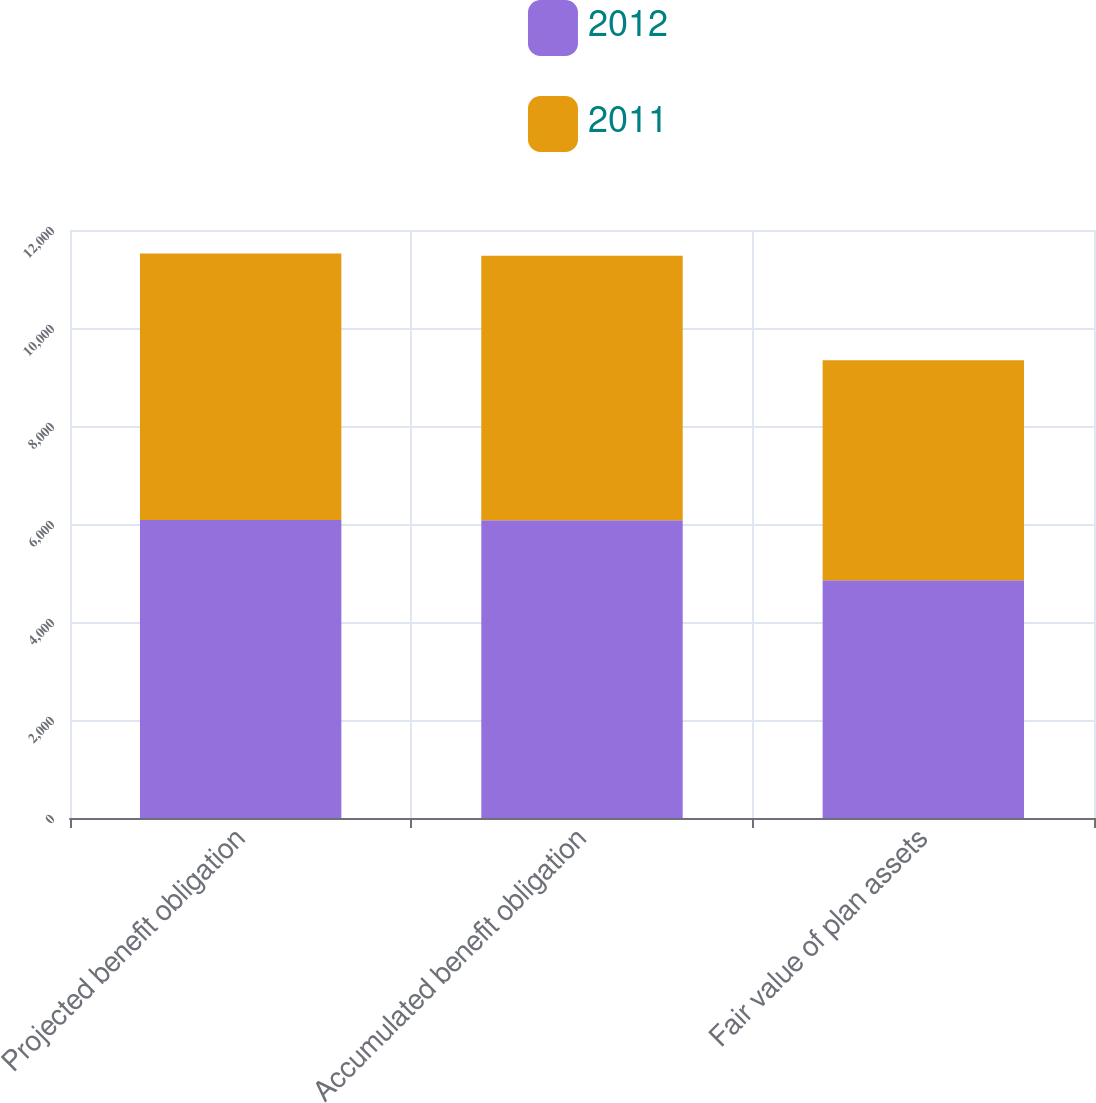<chart> <loc_0><loc_0><loc_500><loc_500><stacked_bar_chart><ecel><fcel>Projected benefit obligation<fcel>Accumulated benefit obligation<fcel>Fair value of plan assets<nl><fcel>2012<fcel>6080<fcel>6079<fcel>4850<nl><fcel>2011<fcel>5441<fcel>5394<fcel>4492<nl></chart> 